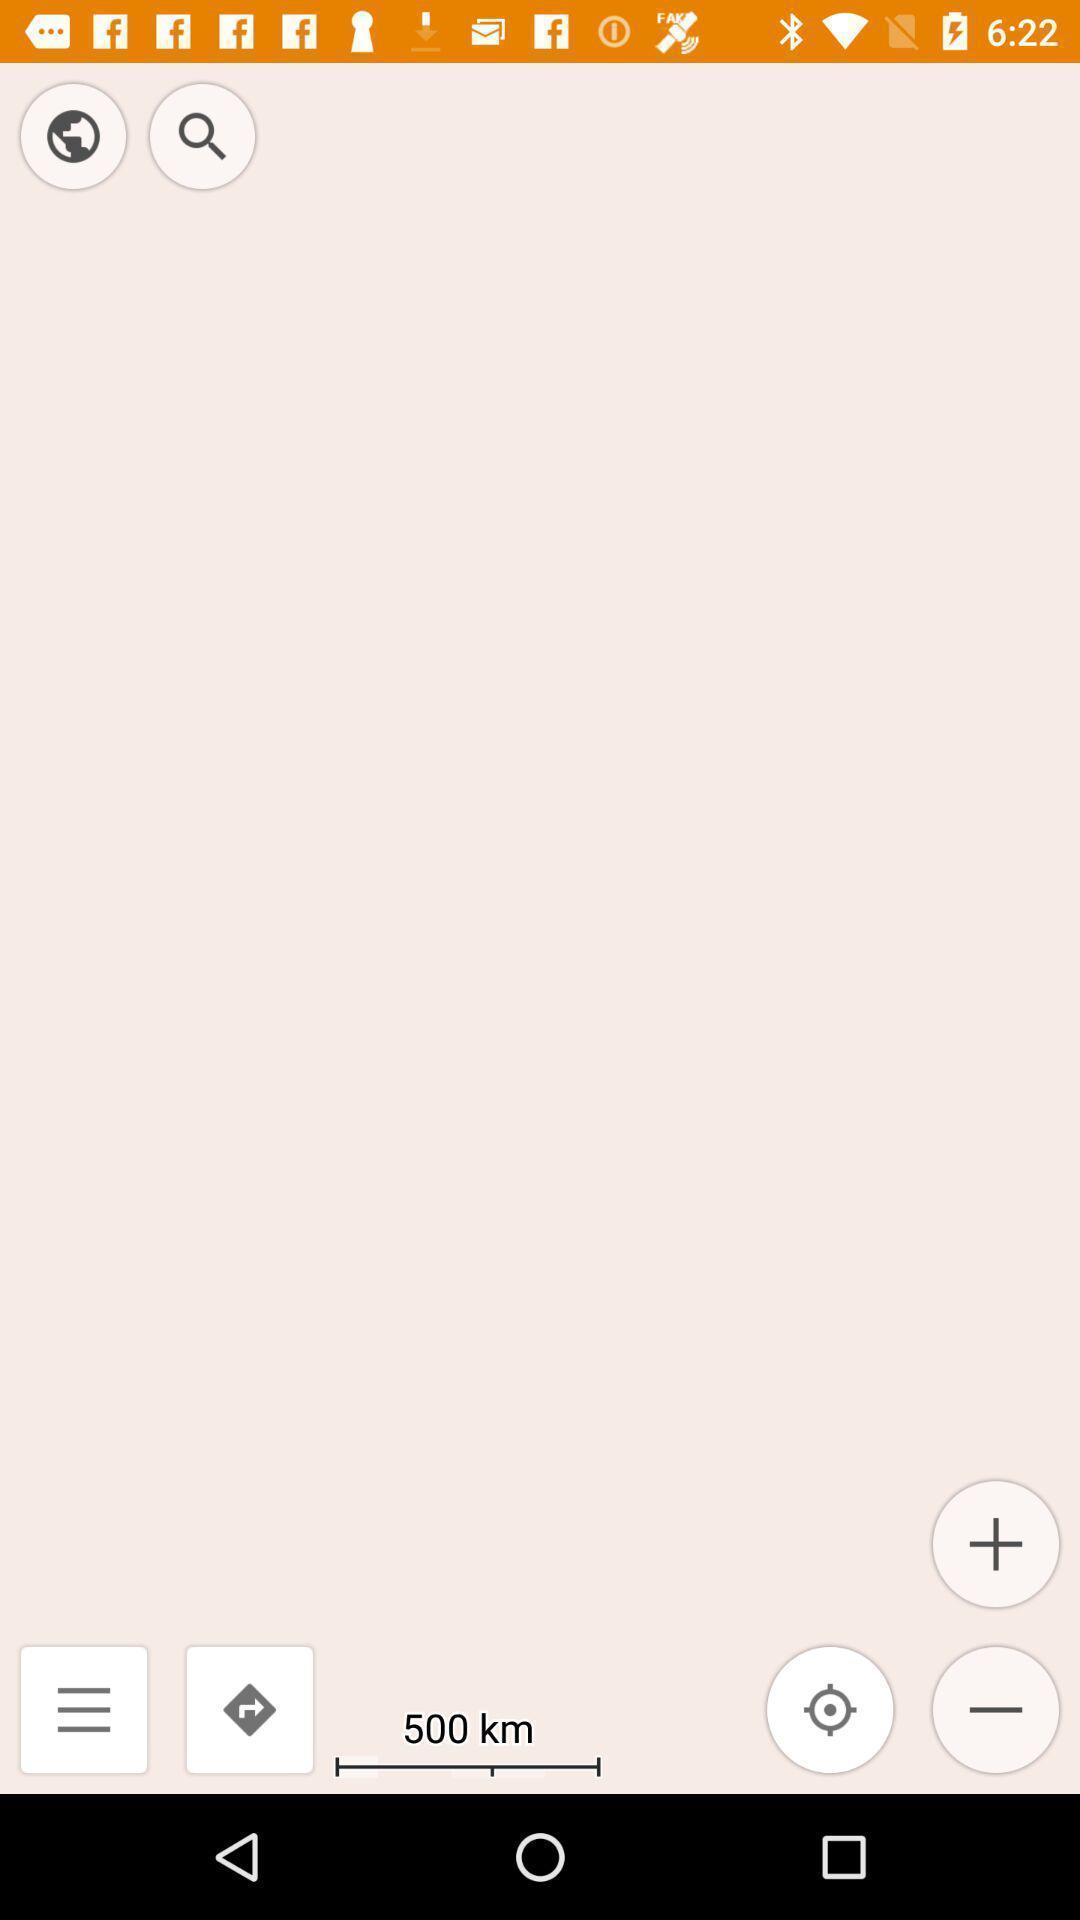Summarize the information in this screenshot. Window displaying offline navigation app. 